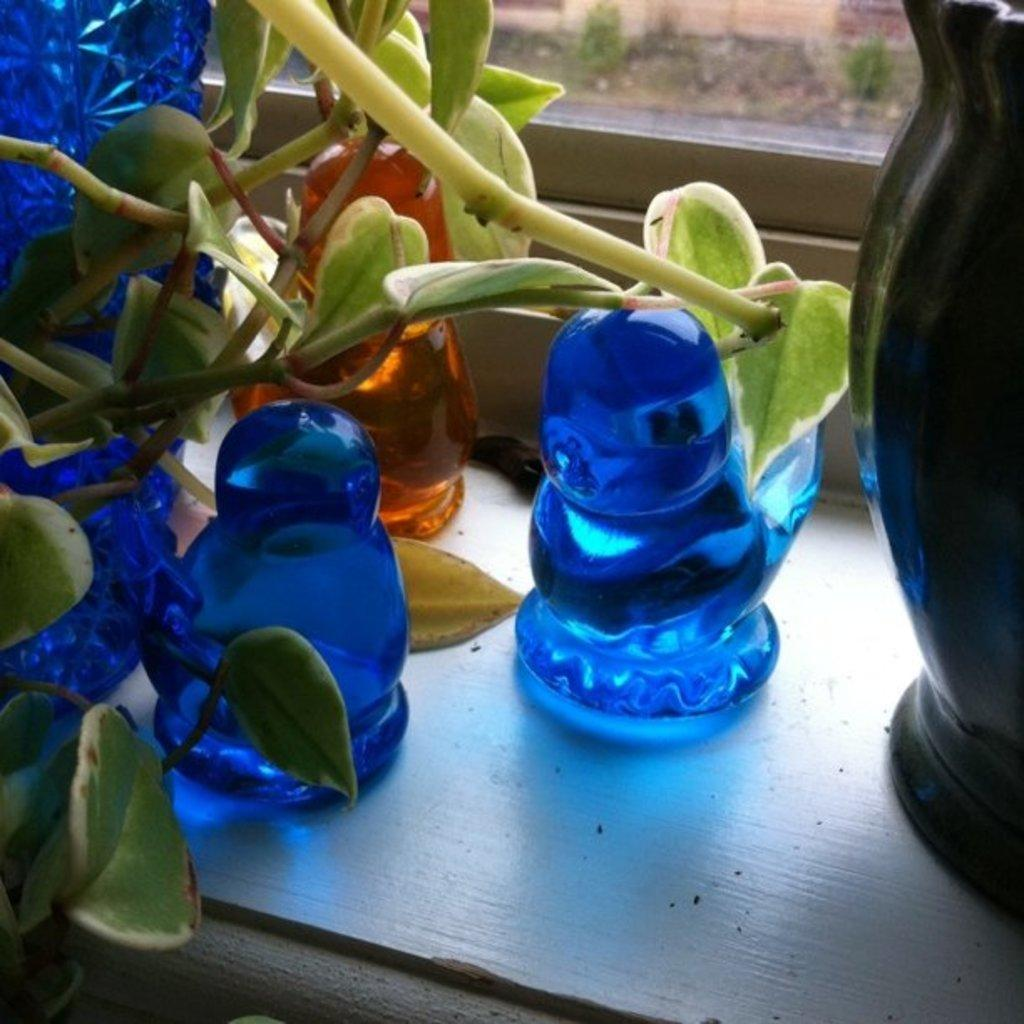What objects are in the foreground of the image? There are flower pots and a plant in the foreground of the image. Are there any other flower pots visible in the image? Yes, there is another flower pot on the right side of the image. Where are these objects located? These objects are on a surface. What can be seen in the background of the image? There is a glass window in the background of the image. What type of building is depicted in the image? There is no building depicted in the image; it primarily features flower pots and a plant. What emotion is the plant feeling in the image? Plants do not have emotions, so it is not possible to determine what emotion the plant might be feeling. 